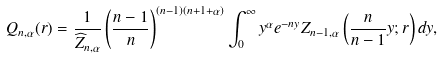Convert formula to latex. <formula><loc_0><loc_0><loc_500><loc_500>Q _ { n , \alpha } ( r ) = \frac { 1 } { \widehat { Z } _ { n , \alpha } } \left ( \frac { n - 1 } { n } \right ) ^ { ( n - 1 ) ( n + 1 + \alpha ) } \int _ { 0 } ^ { \infty } y ^ { \alpha } e ^ { - n y } Z _ { n - 1 , \alpha } \left ( \frac { n } { n - 1 } y ; r \right ) d y ,</formula> 